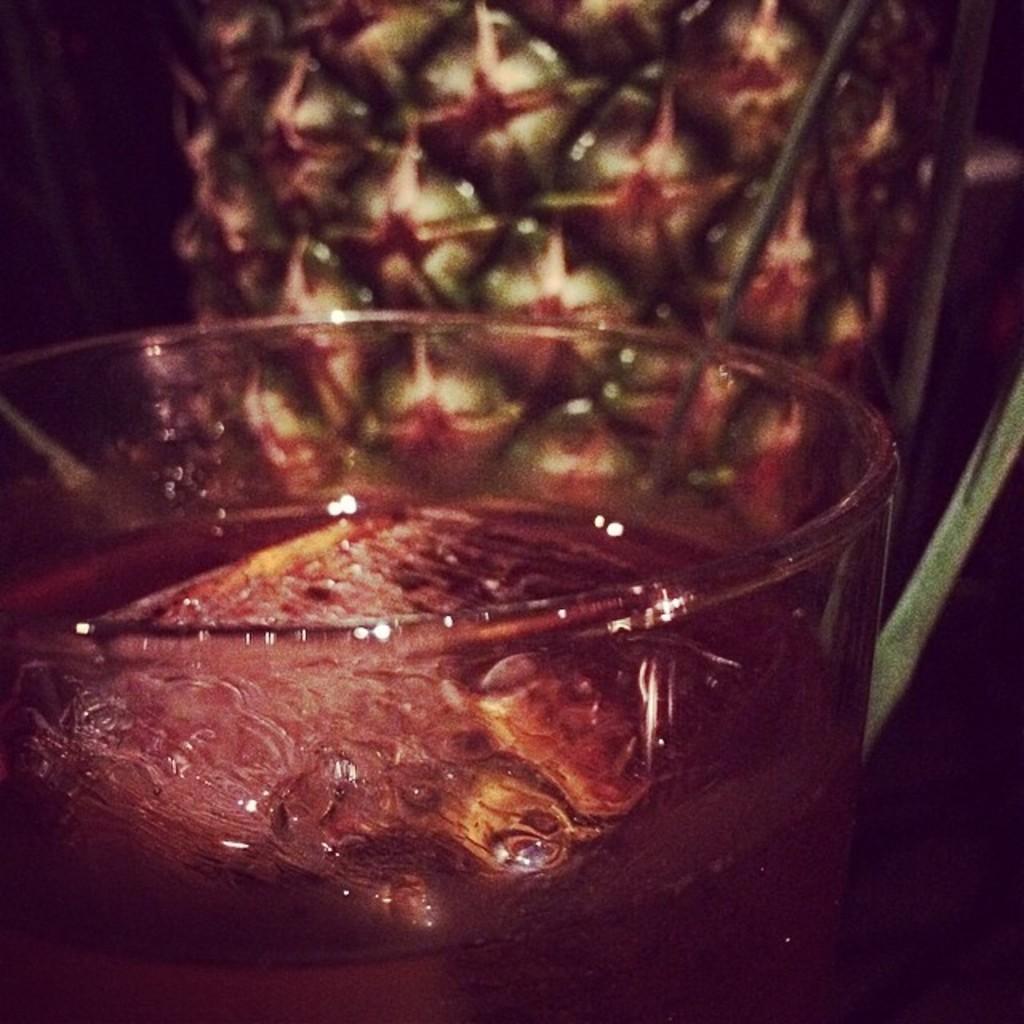In one or two sentences, can you explain what this image depicts? In this image, we can see a glass with some liquid and an object. In the background, we can see an object. We can also see an object on the right. 